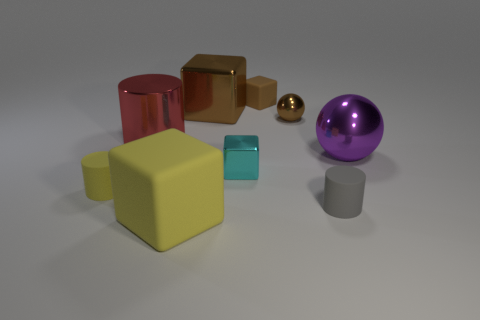Subtract 1 blocks. How many blocks are left? 3 Subtract all gray blocks. Subtract all green cylinders. How many blocks are left? 4 Add 1 large red things. How many objects exist? 10 Subtract all balls. How many objects are left? 7 Subtract all red metal objects. Subtract all big brown metal things. How many objects are left? 7 Add 1 small brown spheres. How many small brown spheres are left? 2 Add 3 small metal objects. How many small metal objects exist? 5 Subtract 0 cyan cylinders. How many objects are left? 9 